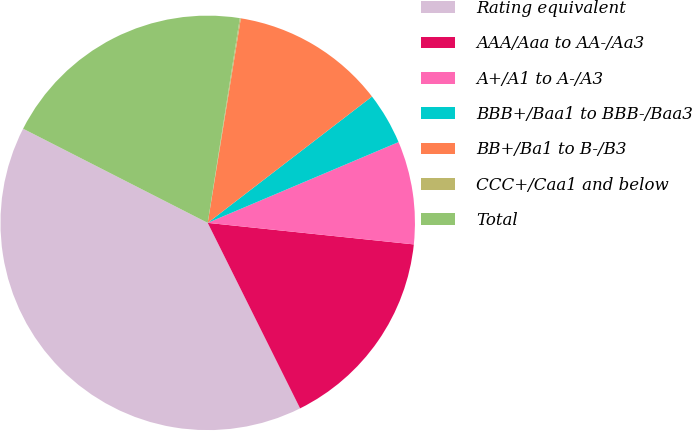Convert chart to OTSL. <chart><loc_0><loc_0><loc_500><loc_500><pie_chart><fcel>Rating equivalent<fcel>AAA/Aaa to AA-/Aa3<fcel>A+/A1 to A-/A3<fcel>BBB+/Baa1 to BBB-/Baa3<fcel>BB+/Ba1 to B-/B3<fcel>CCC+/Caa1 and below<fcel>Total<nl><fcel>39.86%<fcel>15.99%<fcel>8.03%<fcel>4.06%<fcel>12.01%<fcel>0.08%<fcel>19.97%<nl></chart> 